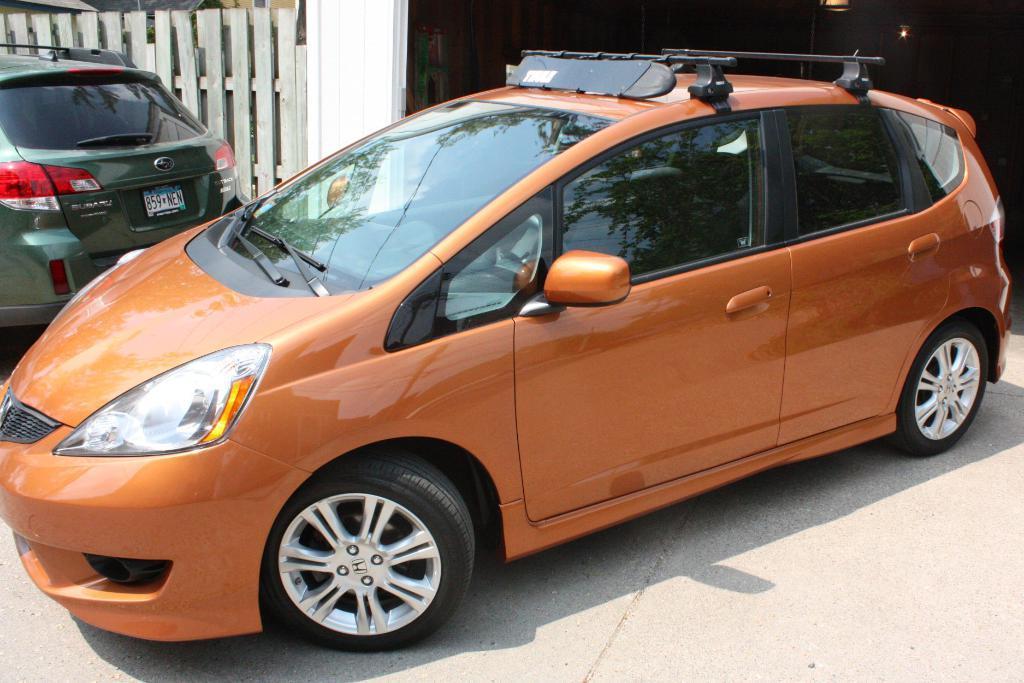In one or two sentences, can you explain what this image depicts? In this image in front there are cars on the road. Behind the cars there is a fence. In the background of the image there are lights. 